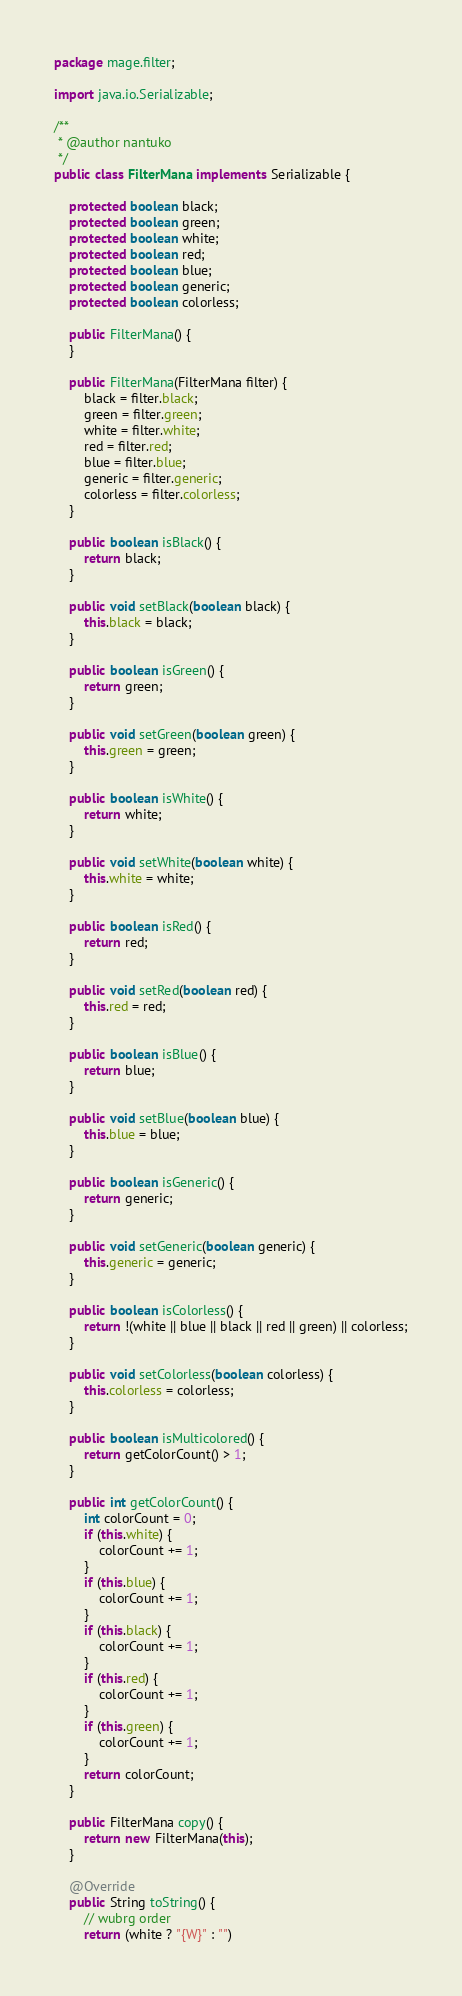Convert code to text. <code><loc_0><loc_0><loc_500><loc_500><_Java_>package mage.filter;

import java.io.Serializable;

/**
 * @author nantuko
 */
public class FilterMana implements Serializable {

    protected boolean black;
    protected boolean green;
    protected boolean white;
    protected boolean red;
    protected boolean blue;
    protected boolean generic;
    protected boolean colorless;

    public FilterMana() {
    }

    public FilterMana(FilterMana filter) {
        black = filter.black;
        green = filter.green;
        white = filter.white;
        red = filter.red;
        blue = filter.blue;
        generic = filter.generic;
        colorless = filter.colorless;
    }

    public boolean isBlack() {
        return black;
    }

    public void setBlack(boolean black) {
        this.black = black;
    }

    public boolean isGreen() {
        return green;
    }

    public void setGreen(boolean green) {
        this.green = green;
    }

    public boolean isWhite() {
        return white;
    }

    public void setWhite(boolean white) {
        this.white = white;
    }

    public boolean isRed() {
        return red;
    }

    public void setRed(boolean red) {
        this.red = red;
    }

    public boolean isBlue() {
        return blue;
    }

    public void setBlue(boolean blue) {
        this.blue = blue;
    }

    public boolean isGeneric() {
        return generic;
    }

    public void setGeneric(boolean generic) {
        this.generic = generic;
    }

    public boolean isColorless() {
        return !(white || blue || black || red || green) || colorless;
    }

    public void setColorless(boolean colorless) {
        this.colorless = colorless;
    }

    public boolean isMulticolored() {
        return getColorCount() > 1;
    }

    public int getColorCount() {
        int colorCount = 0;
        if (this.white) {
            colorCount += 1;
        }
        if (this.blue) {
            colorCount += 1;
        }
        if (this.black) {
            colorCount += 1;
        }
        if (this.red) {
            colorCount += 1;
        }
        if (this.green) {
            colorCount += 1;
        }
        return colorCount;
    }

    public FilterMana copy() {
        return new FilterMana(this);
    }

    @Override
    public String toString() {
        // wubrg order
        return (white ? "{W}" : "")</code> 